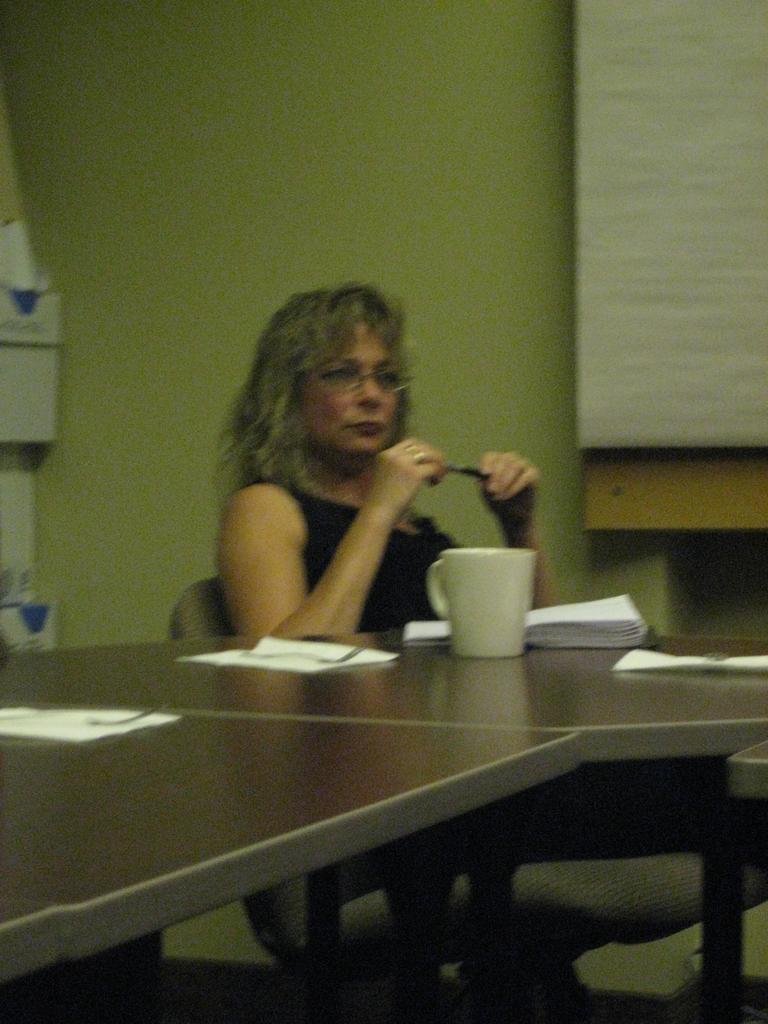In one or two sentences, can you explain what this image depicts? In this image we can see a woman sitting on the chair by holding a pen in her hands. In front of her there is a table upon which a cup, few papers are placed on it. In the background there is a wall. 